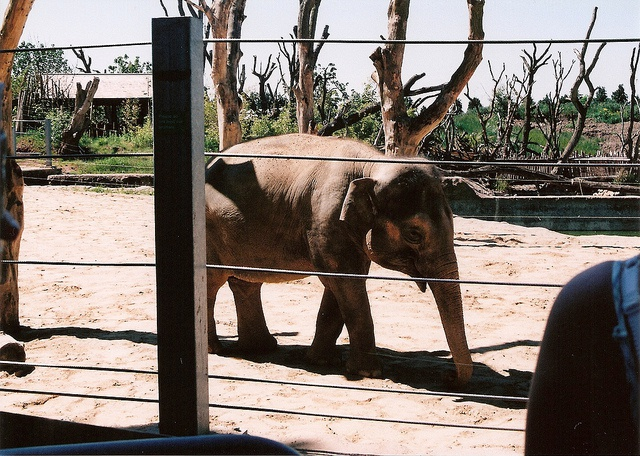Describe the objects in this image and their specific colors. I can see elephant in lightgray, black, maroon, and tan tones and people in lightgray, black, navy, blue, and gray tones in this image. 